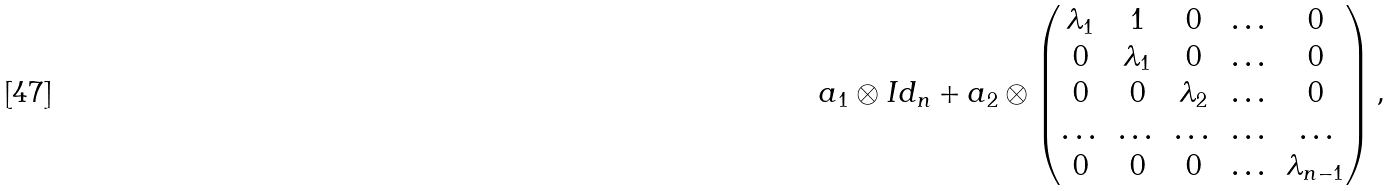Convert formula to latex. <formula><loc_0><loc_0><loc_500><loc_500>a _ { 1 } \otimes I d _ { n } + a _ { 2 } \otimes \begin{pmatrix} \lambda _ { 1 } & 1 & 0 & \dots & 0 \\ 0 & \lambda _ { 1 } & 0 & \dots & 0 \\ 0 & 0 & \lambda _ { 2 } & \dots & 0 \\ \dots & \dots & \dots & \dots & \dots \\ 0 & 0 & 0 & \dots & \lambda _ { n - 1 } \\ \end{pmatrix} ,</formula> 